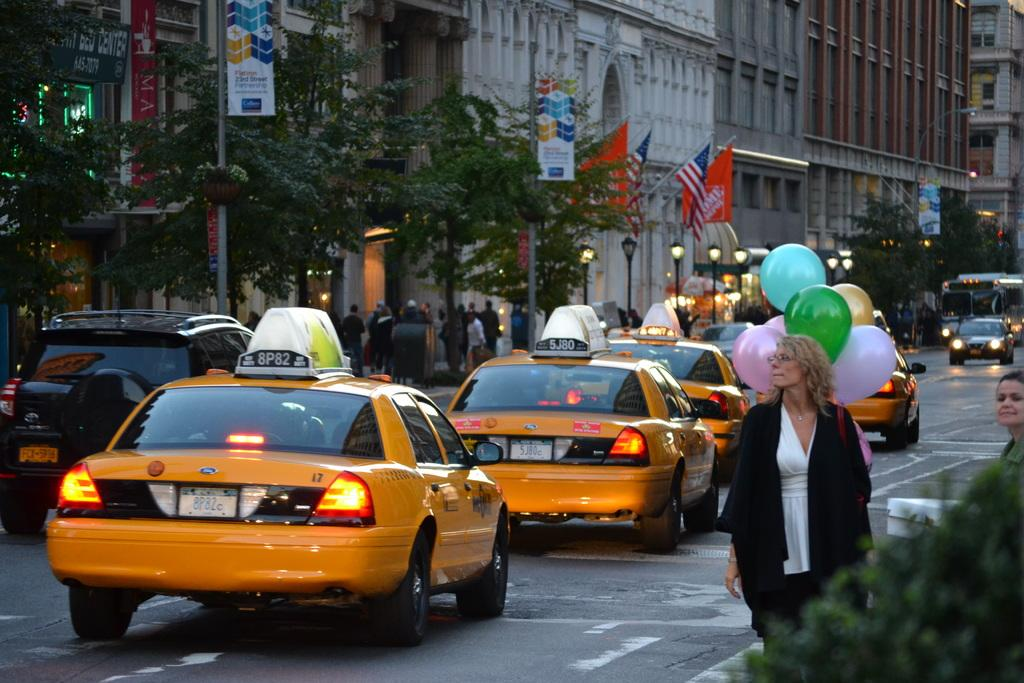<image>
Render a clear and concise summary of the photo. A taxi is driving on the street with 8P82 on the light on top. 